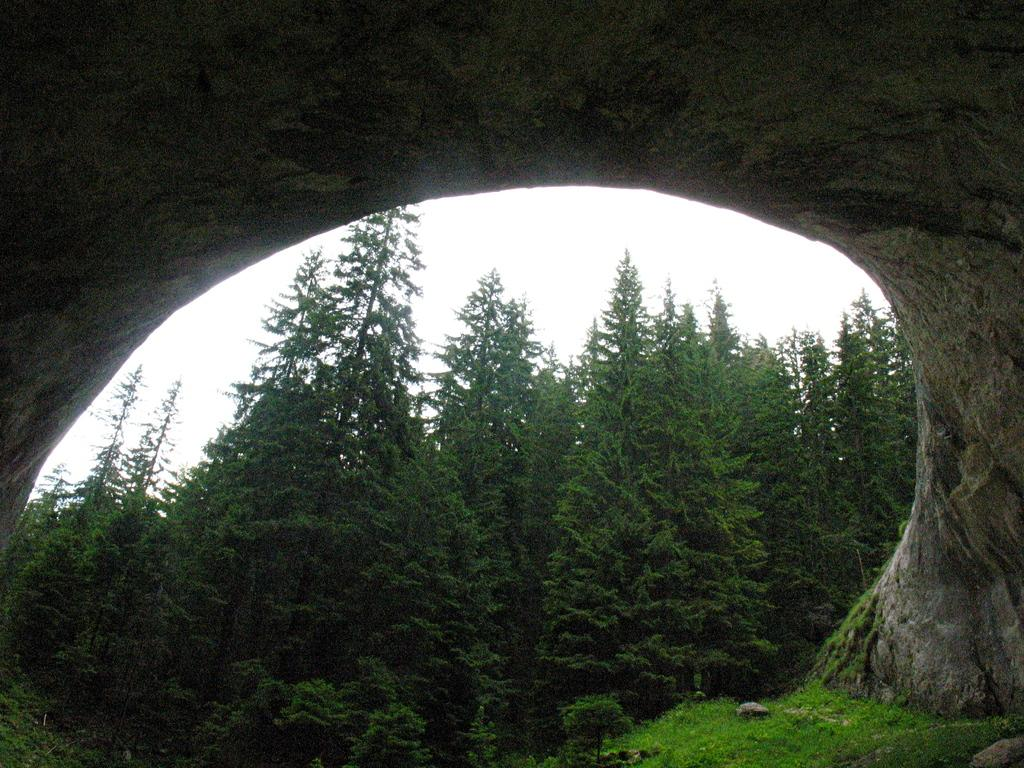What type of structure is present in the image? There is a stone arch in the image. What is the ground surface like in the image? There is grass on the ground in the image. What type of vegetation is present in the image? There are many trees in the image. What can be seen in the background of the image? The sky is visible in the background of the image. What type of ship can be seen sailing on the ground in the image? There is no ship present in the image; it features a stone arch, grass, trees, and the sky. What type of work is being done by the trees in the image? Trees do not perform work; they are plants that provide oxygen and shade. 